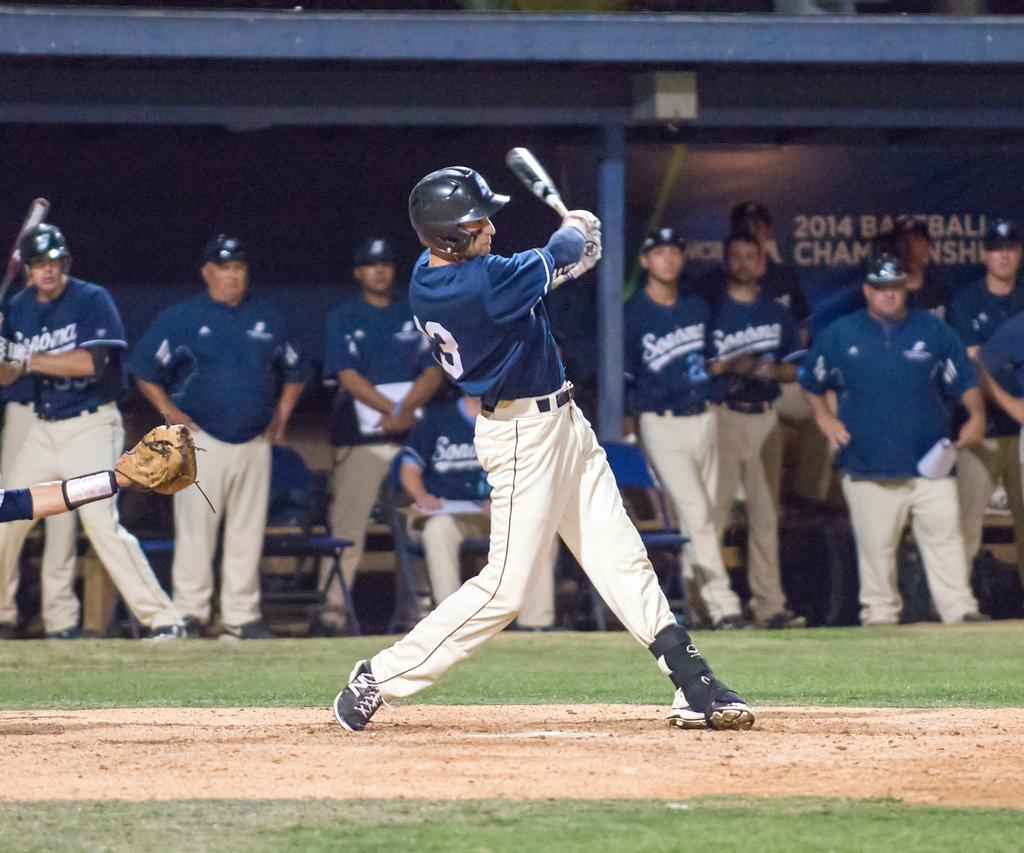<image>
Provide a brief description of the given image. A baseball in a jersey with the number 13 on it. 